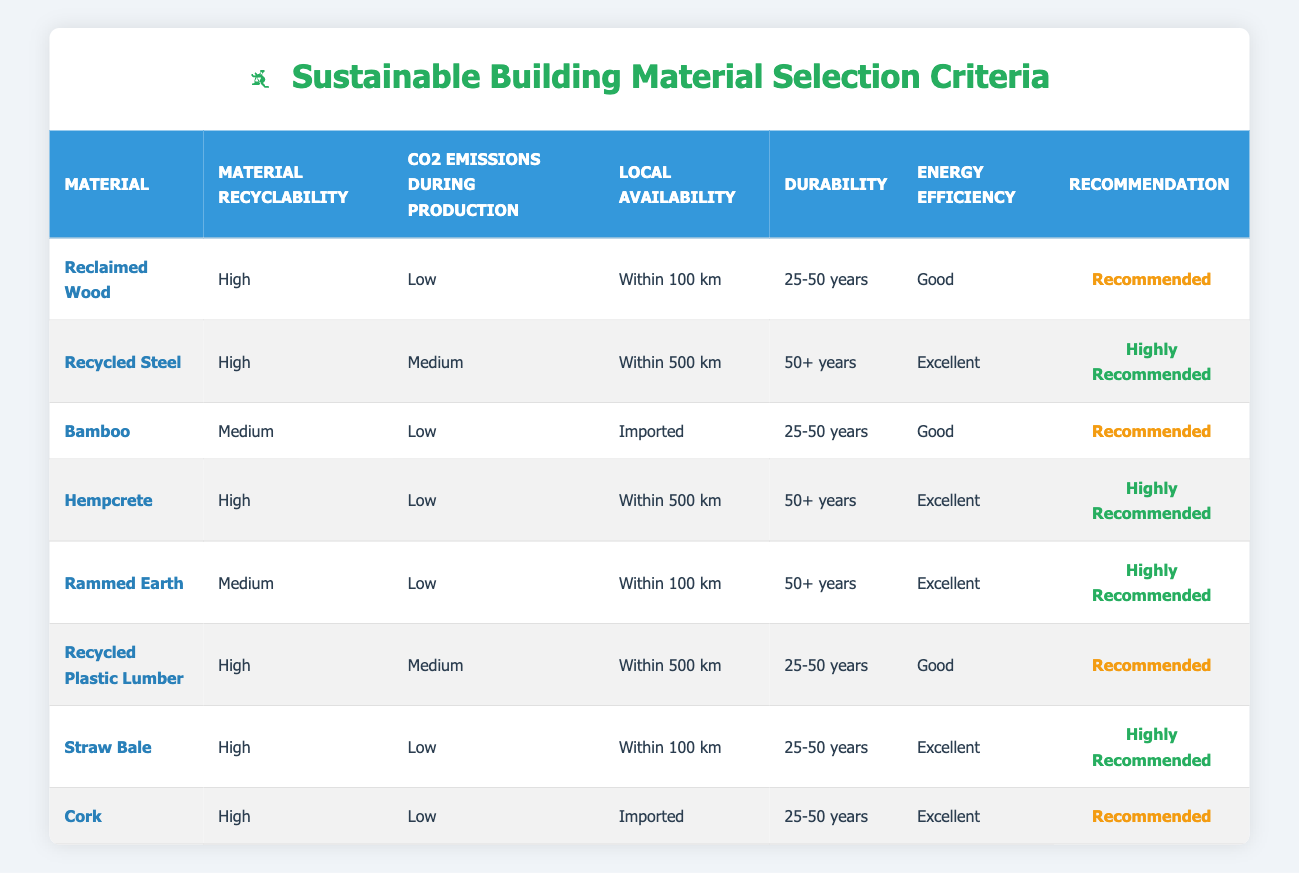What is the recommendation for Recycled Steel? The table lists the recommendation for Recycled Steel in the last column. It states "Highly Recommended".
Answer: Highly Recommended Which material has the lowest CO2 emissions during production? By examining the CO2 emissions column, "Low" appears for several materials. However, Reclaimed Wood, Bamboo, and Straw Bale all have low emissions. Therefore, we look at the recommendations to see if they differ, but they all lead to "Recommended" or "Highly Recommended" status.
Answer: Reclaimed Wood, Bamboo, Straw Bale Is Rammed Earth considered "Not Recommended"? Looking at the recommendation column for Rammed Earth, we can see it is listed as "Highly Recommended". Therefore, it is not considered "Not Recommended".
Answer: No How many materials are within 100 km and have a recommendation of "Highly Recommended"? We need to filter the table by local availability for the option "Within 100 km". The materials that fall under this criteria and have "Highly Recommended" are Recycled Steel and Straw Bale. Count them gives a total of 2.
Answer: 2 Which material has the best combination of recyclability and energy efficiency? By analyzing the table, Recycler Steel and Hempcrete both have "High" recyclability and "Excellent" energy efficiency as their attributes. They are the only materials matching this criterion.
Answer: Recycled Steel, Hempcrete What is the CO2 emission level of the material recommended for "Rammed Earth"? The CO2 emission level for Rammed Earth in the table is "Low". This value can be found directly in the corresponding column for this material.
Answer: Low Are there any materials that are both imported and considered "Highly Recommended"? Referring to the materials listed in the table, we can find that the materials which are imported are Bamboo and Cork. Both of these have “Recommended” status and thus do not meet the "Highly Recommended" criteria.
Answer: No What is the average durability of the materials that are "Recommended"? The "Recommended" status applies to Reclaimed Wood, Bamboo, Hempcrete, Recycled Plastic Lumber, and Cork, with durabilities of 25-50 years (2), 25-50 years (2), 50+ years (1), 25-50 years (2) respectively. Summing up gives: 2*37.5 + 1*50 + 2*37.5 = 162.5. Dividing this by 5 gives an average of 32.5 years.
Answer: 32.5 years 